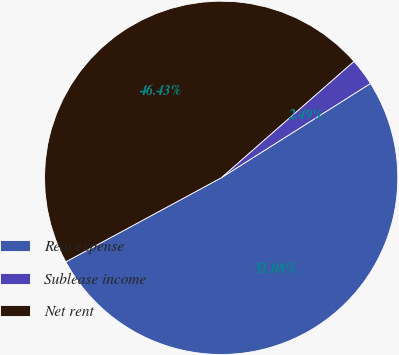Convert chart. <chart><loc_0><loc_0><loc_500><loc_500><pie_chart><fcel>Rent expense<fcel>Sublease income<fcel>Net rent<nl><fcel>51.08%<fcel>2.49%<fcel>46.43%<nl></chart> 